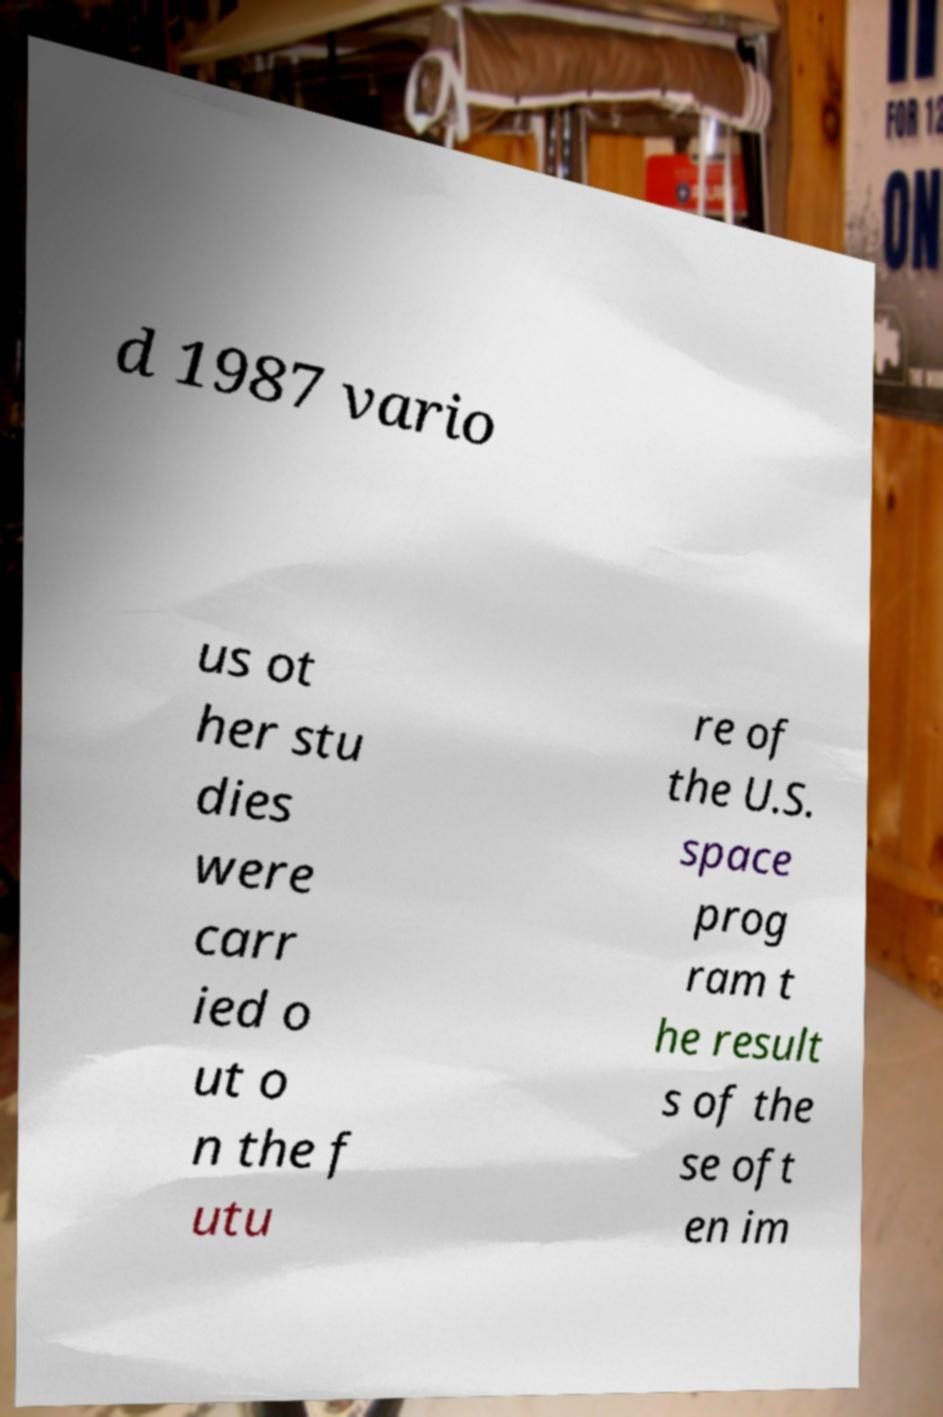Can you accurately transcribe the text from the provided image for me? d 1987 vario us ot her stu dies were carr ied o ut o n the f utu re of the U.S. space prog ram t he result s of the se oft en im 